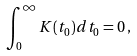<formula> <loc_0><loc_0><loc_500><loc_500>\int _ { 0 } ^ { \infty } K ( t _ { 0 } ) d t _ { 0 } = 0 \, ,</formula> 